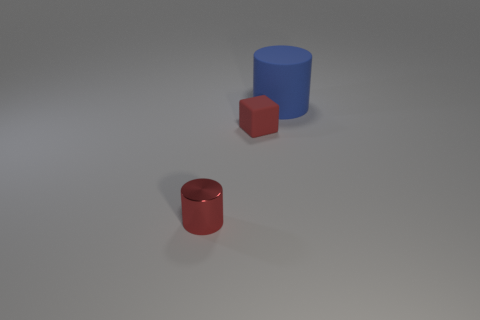What is the cylinder right of the small metallic object made of?
Provide a succinct answer. Rubber. What size is the block that is made of the same material as the large blue cylinder?
Offer a very short reply. Small. Is the size of the red thing left of the tiny red matte thing the same as the rubber object that is left of the blue matte cylinder?
Provide a succinct answer. Yes. There is another object that is the same size as the red rubber thing; what is it made of?
Provide a succinct answer. Metal. What is the object that is in front of the large matte cylinder and to the right of the red metal cylinder made of?
Offer a terse response. Rubber. Are any shiny cylinders visible?
Your answer should be very brief. Yes. There is a rubber cube; is it the same color as the cylinder on the left side of the big blue rubber cylinder?
Provide a short and direct response. Yes. There is a small cylinder that is the same color as the small block; what is it made of?
Make the answer very short. Metal. Is there anything else that has the same shape as the blue matte thing?
Offer a very short reply. Yes. What is the shape of the small thing right of the red object in front of the rubber thing on the left side of the blue thing?
Provide a succinct answer. Cube. 